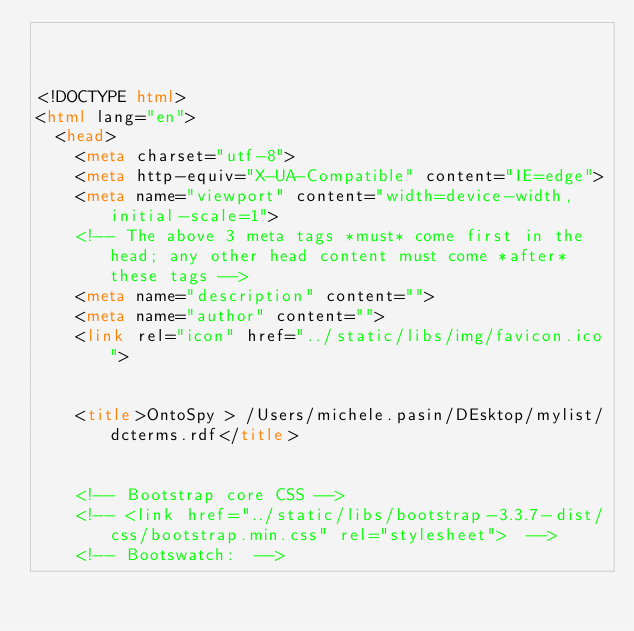<code> <loc_0><loc_0><loc_500><loc_500><_HTML_>


<!DOCTYPE html>
<html lang="en">
  <head>
    <meta charset="utf-8">
    <meta http-equiv="X-UA-Compatible" content="IE=edge">
    <meta name="viewport" content="width=device-width, initial-scale=1">
    <!-- The above 3 meta tags *must* come first in the head; any other head content must come *after* these tags -->
    <meta name="description" content="">
    <meta name="author" content="">
    <link rel="icon" href="../static/libs/img/favicon.ico">

	
		<title>OntoSpy > /Users/michele.pasin/DEsktop/mylist/dcterms.rdf</title>
	

    <!-- Bootstrap core CSS -->
    <!-- <link href="../static/libs/bootstrap-3.3.7-dist/css/bootstrap.min.css" rel="stylesheet">  -->
    <!-- Bootswatch:  --></code> 